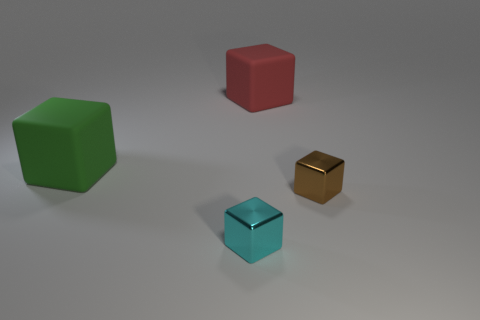What colors are the objects in the image? The objects in the image include a green cube, a red cube, a cyan cube, and a brown cube. Are any of the cubes larger than the others? Yes, the red cube appears to be larger than the other cubes in the image. 